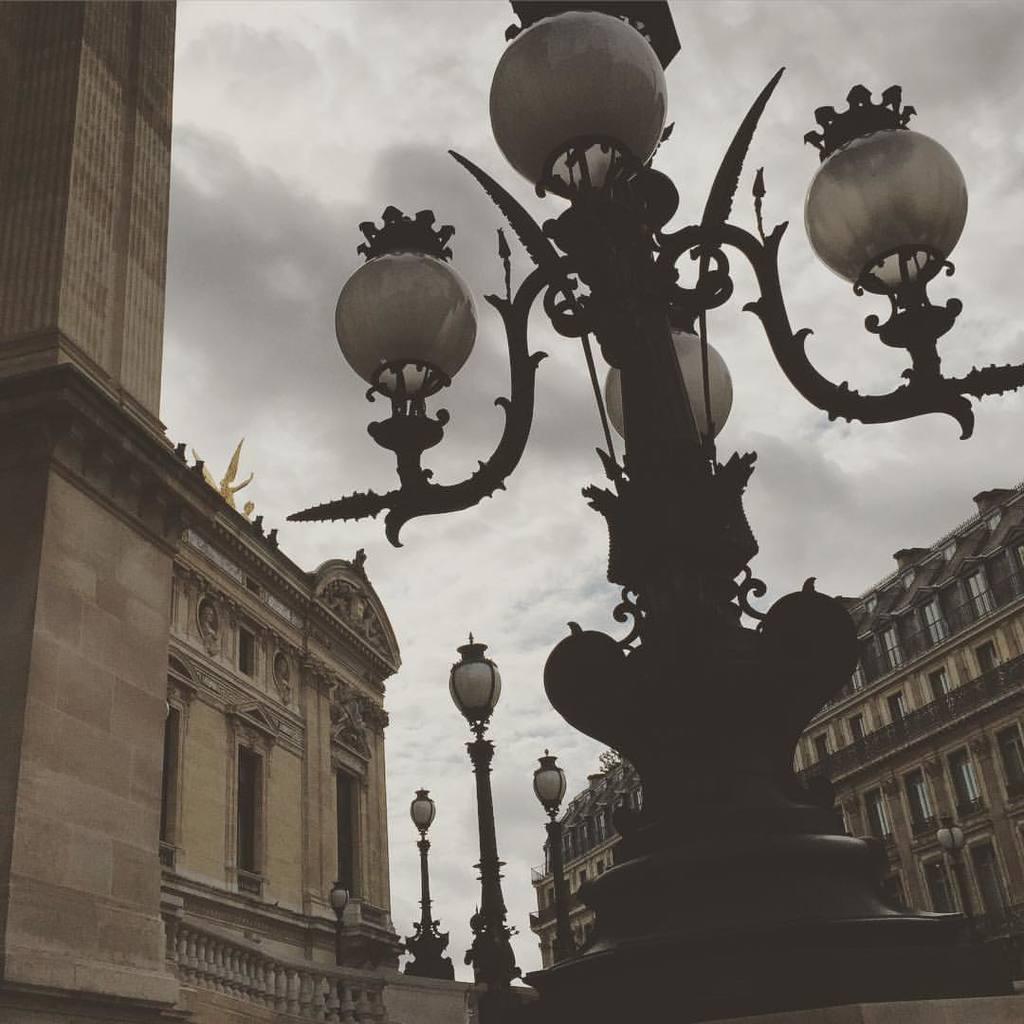Could you give a brief overview of what you see in this image? In this image, we can see street lights, poles, walls, buildings, railings and windows. Background there is a cloudy sky. 